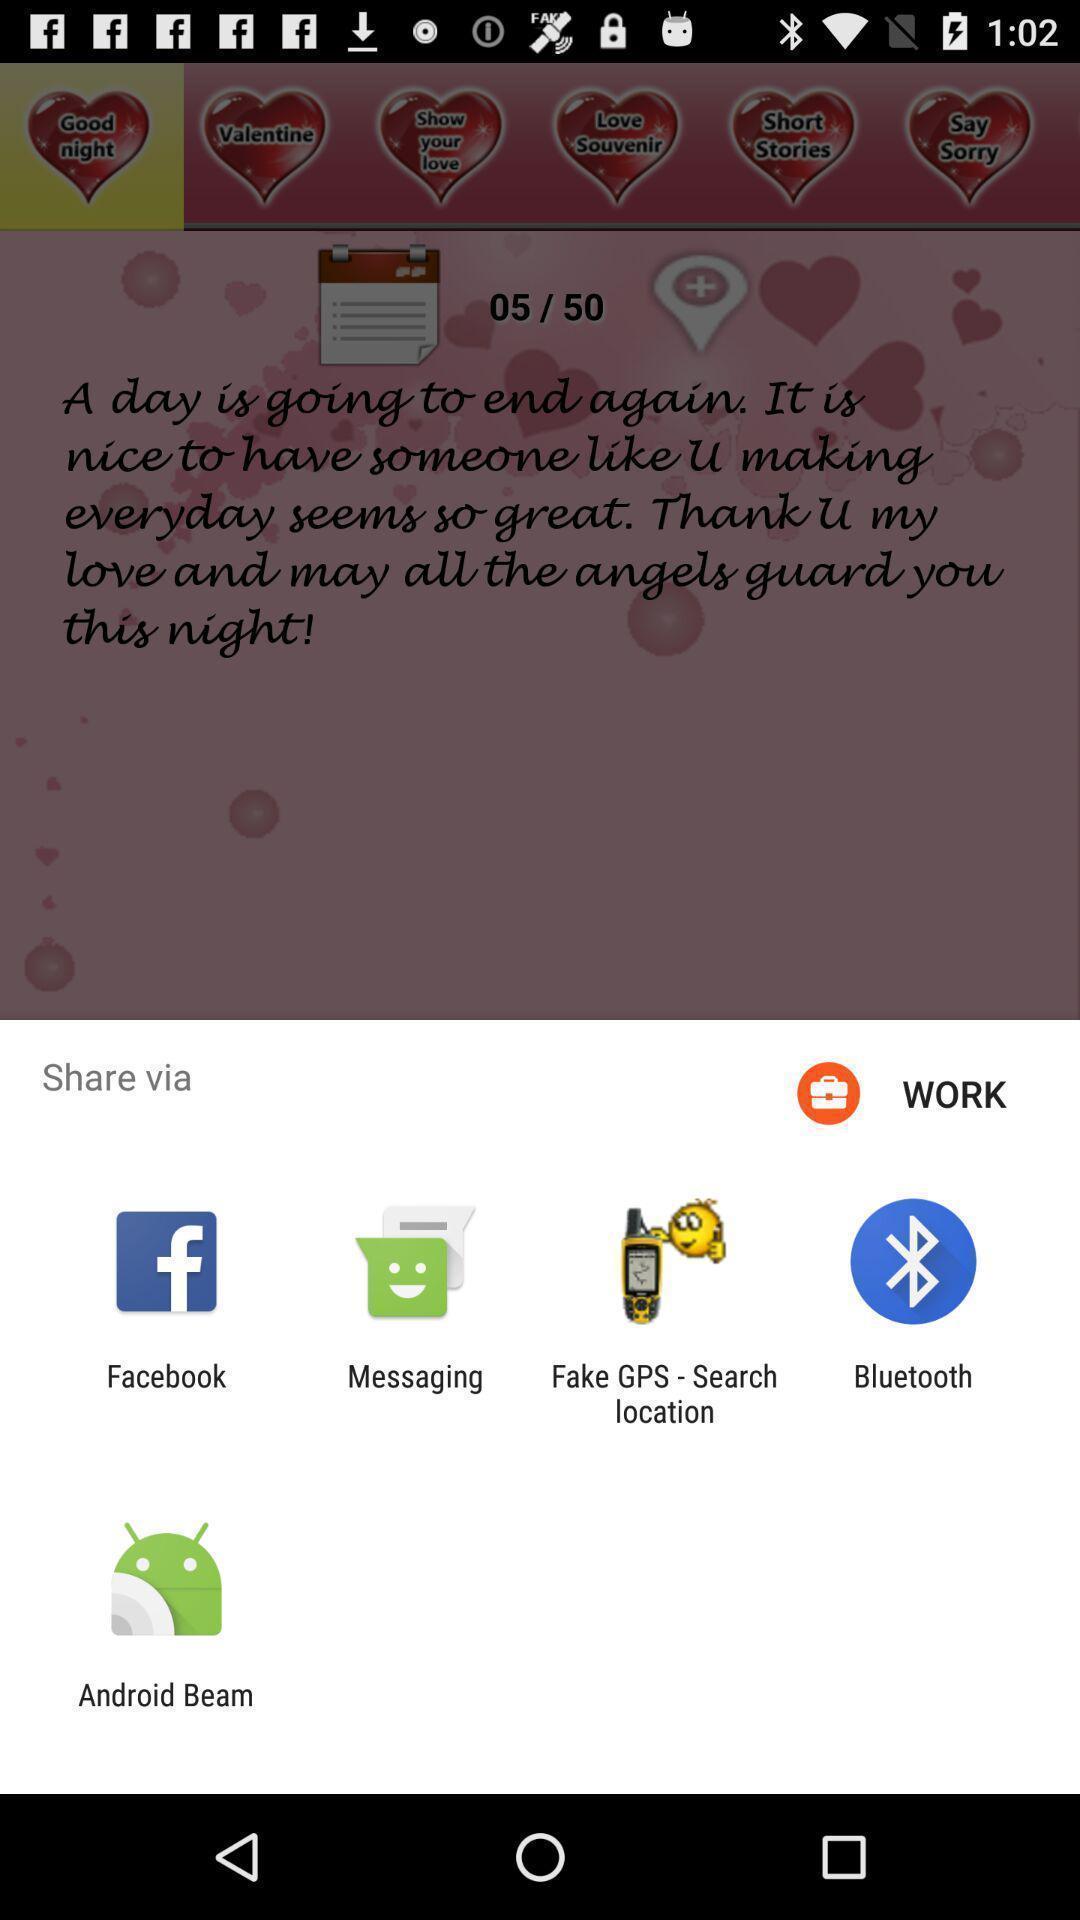Summarize the information in this screenshot. Pop-up showing the multiple share options. 